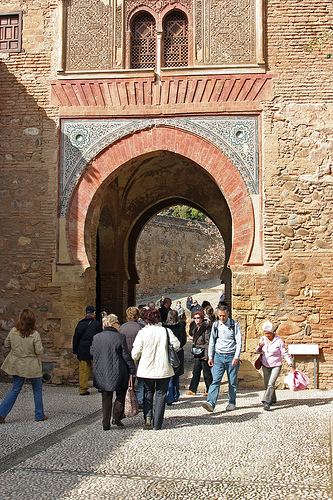<image>
Is there a pants on the woman? Yes. Looking at the image, I can see the pants is positioned on top of the woman, with the woman providing support. 